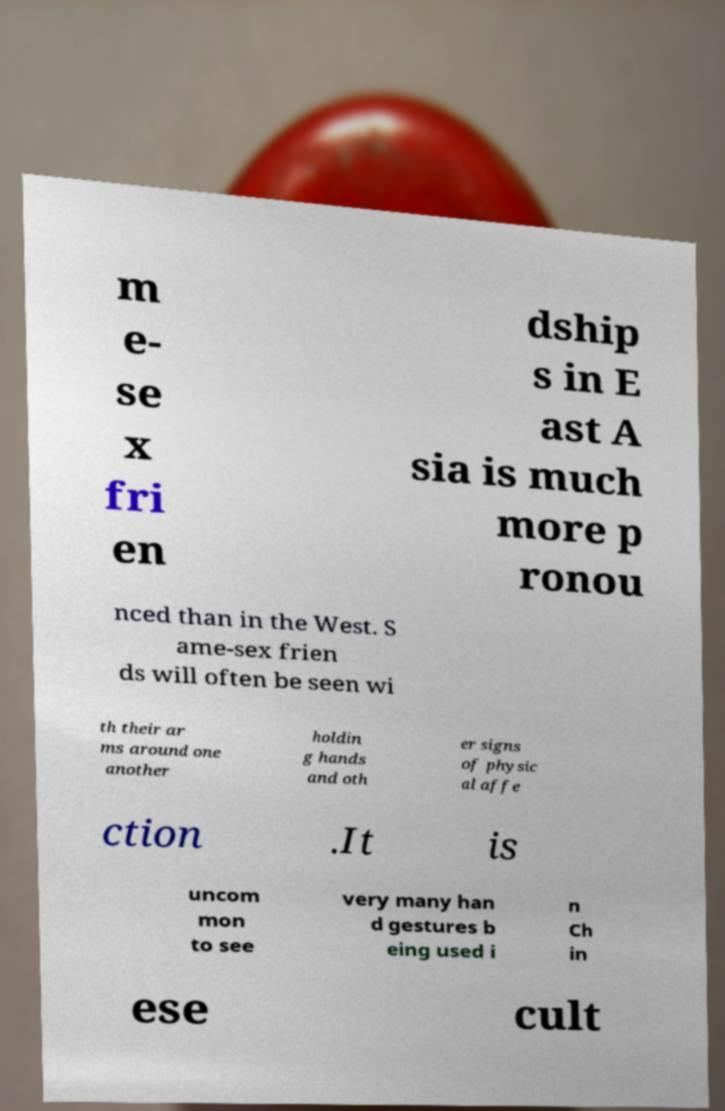Please identify and transcribe the text found in this image. m e- se x fri en dship s in E ast A sia is much more p ronou nced than in the West. S ame-sex frien ds will often be seen wi th their ar ms around one another holdin g hands and oth er signs of physic al affe ction .It is uncom mon to see very many han d gestures b eing used i n Ch in ese cult 